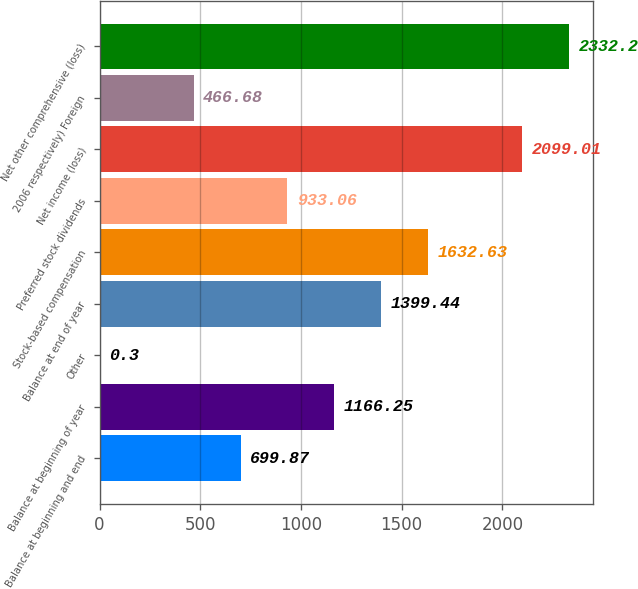Convert chart to OTSL. <chart><loc_0><loc_0><loc_500><loc_500><bar_chart><fcel>Balance at beginning and end<fcel>Balance at beginning of year<fcel>Other<fcel>Balance at end of year<fcel>Stock-based compensation<fcel>Preferred stock dividends<fcel>Net income (loss)<fcel>2006 respectively) Foreign<fcel>Net other comprehensive (loss)<nl><fcel>699.87<fcel>1166.25<fcel>0.3<fcel>1399.44<fcel>1632.63<fcel>933.06<fcel>2099.01<fcel>466.68<fcel>2332.2<nl></chart> 